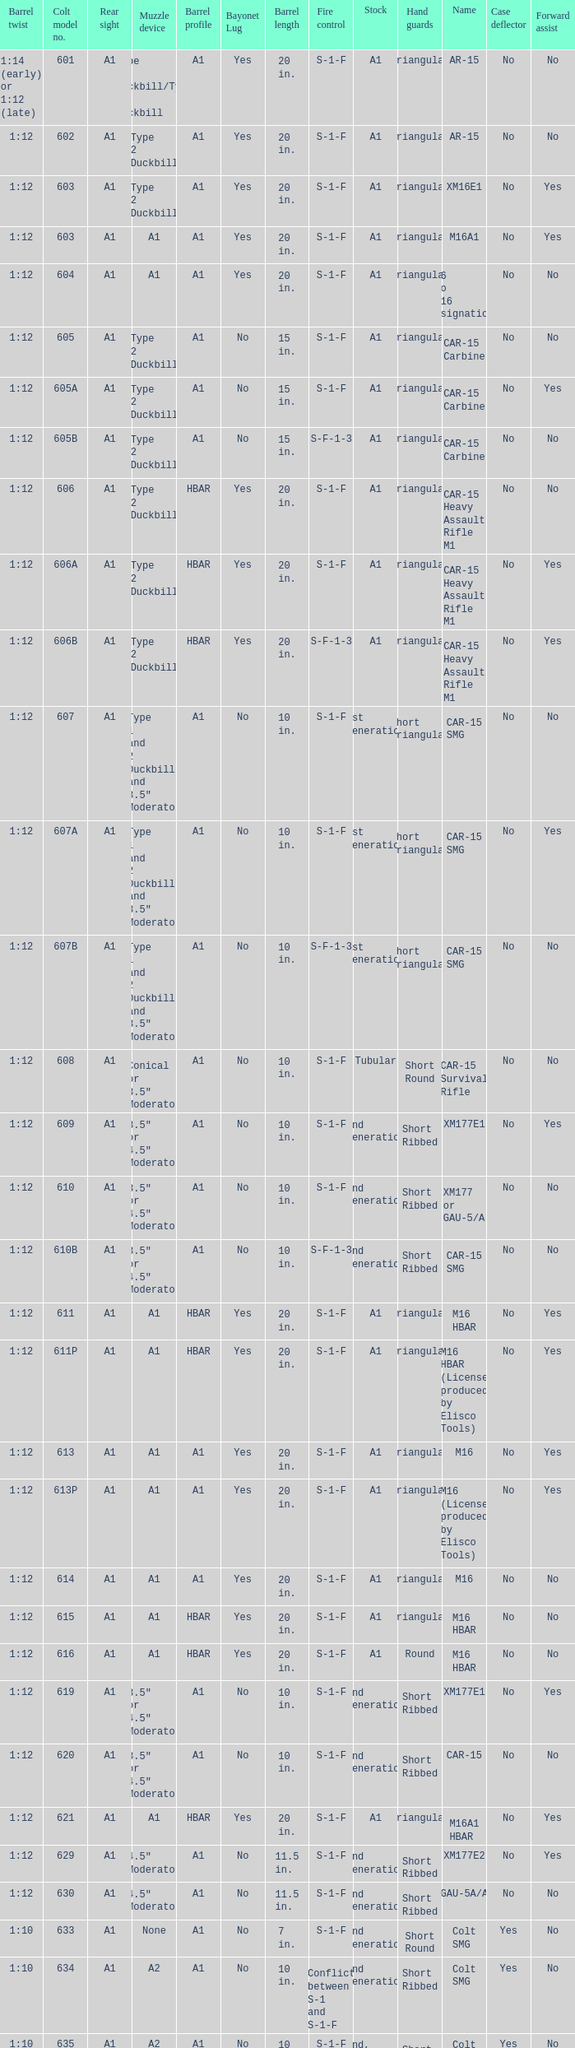What are the Colt model numbers of the models named GAU-5A/A, with no bayonet lug, no case deflector and stock of 2nd generation?  630, 649. 